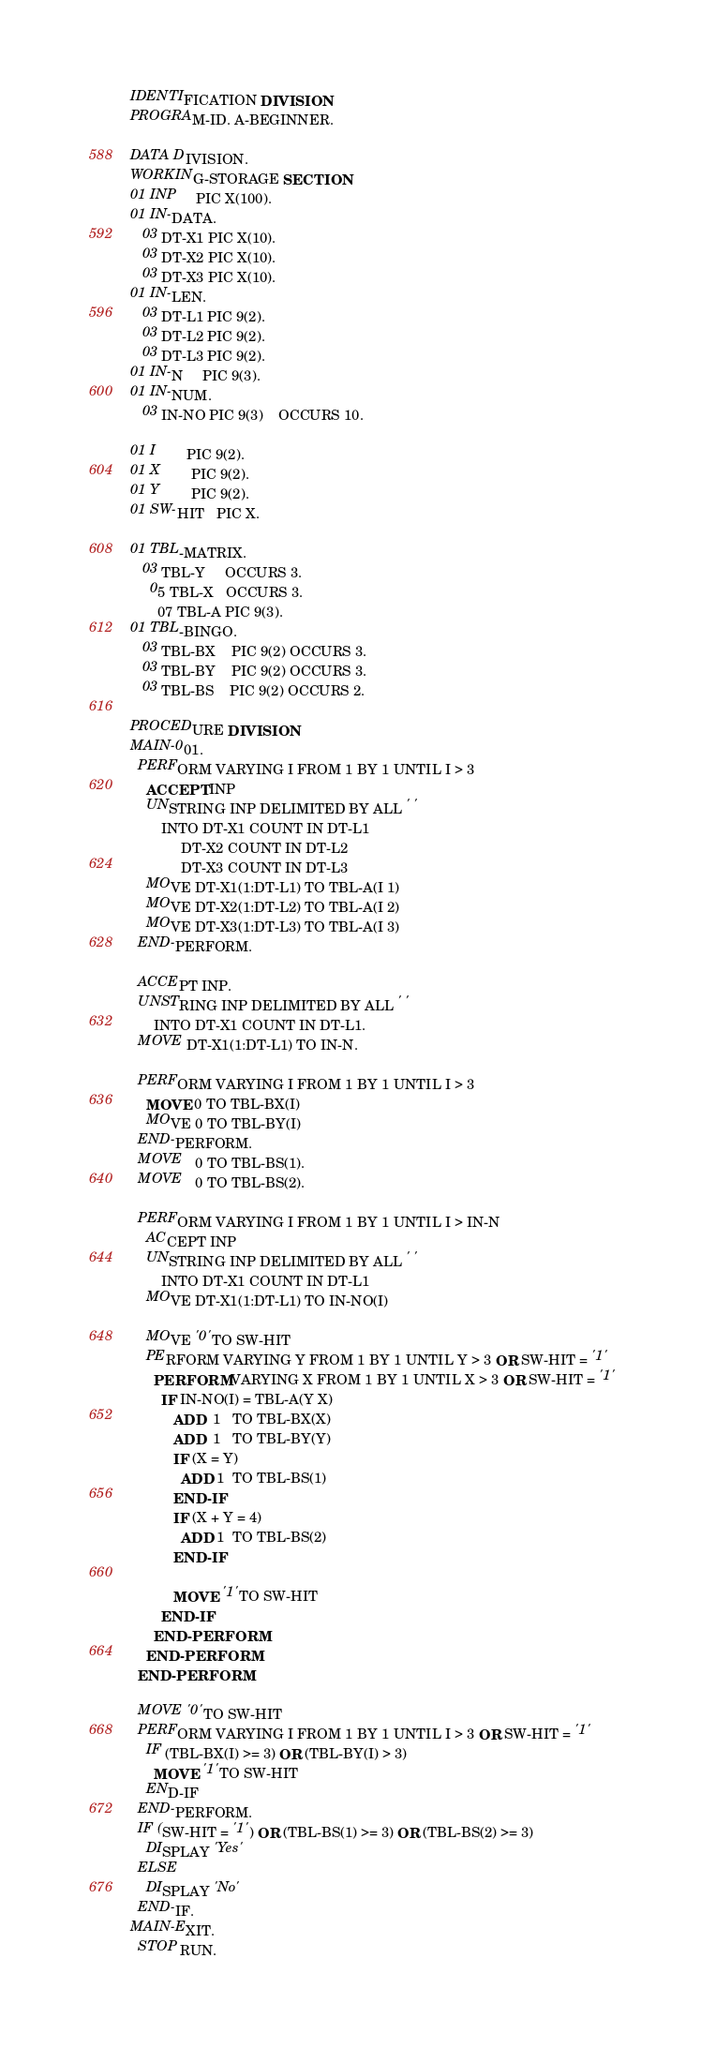Convert code to text. <code><loc_0><loc_0><loc_500><loc_500><_COBOL_>IDENTIFICATION DIVISION.
PROGRAM-ID. A-BEGINNER.
 
DATA DIVISION.
WORKING-STORAGE SECTION.
01 INP     PIC X(100).
01 IN-DATA.
   03 DT-X1 PIC X(10).
   03 DT-X2 PIC X(10).
   03 DT-X3 PIC X(10).
01 IN-LEN.
   03 DT-L1 PIC 9(2).
   03 DT-L2 PIC 9(2).
   03 DT-L3 PIC 9(2).
01 IN-N     PIC 9(3).
01 IN-NUM.
   03 IN-NO PIC 9(3)    OCCURS 10.

01 I        PIC 9(2).
01 X        PIC 9(2). 
01 Y        PIC 9(2). 
01 SW-HIT   PIC X.

01 TBL-MATRIX.
   03 TBL-Y     OCCURS 3.
     05 TBL-X   OCCURS 3.
       07 TBL-A PIC 9(3).
01 TBL-BINGO.
   03 TBL-BX    PIC 9(2) OCCURS 3.
   03 TBL-BY    PIC 9(2) OCCURS 3.
   03 TBL-BS    PIC 9(2) OCCURS 2.

PROCEDURE DIVISION.
MAIN-001.
  PERFORM VARYING I FROM 1 BY 1 UNTIL I > 3
    ACCEPT INP
    UNSTRING INP DELIMITED BY ALL ' '
        INTO DT-X1 COUNT IN DT-L1
             DT-X2 COUNT IN DT-L2
             DT-X3 COUNT IN DT-L3
    MOVE DT-X1(1:DT-L1) TO TBL-A(I 1)
    MOVE DT-X2(1:DT-L2) TO TBL-A(I 2)
    MOVE DT-X3(1:DT-L3) TO TBL-A(I 3)
  END-PERFORM. 

  ACCEPT INP.
  UNSTRING INP DELIMITED BY ALL ' '
      INTO DT-X1 COUNT IN DT-L1.
  MOVE DT-X1(1:DT-L1) TO IN-N.

  PERFORM VARYING I FROM 1 BY 1 UNTIL I > 3
    MOVE 0 TO TBL-BX(I)
    MOVE 0 TO TBL-BY(I)
  END-PERFORM.
  MOVE   0 TO TBL-BS(1).
  MOVE   0 TO TBL-BS(2).  

  PERFORM VARYING I FROM 1 BY 1 UNTIL I > IN-N
    ACCEPT INP
    UNSTRING INP DELIMITED BY ALL ' '
        INTO DT-X1 COUNT IN DT-L1
    MOVE DT-X1(1:DT-L1) TO IN-NO(I)

    MOVE '0' TO SW-HIT
    PERFORM VARYING Y FROM 1 BY 1 UNTIL Y > 3 OR SW-HIT = '1'
      PERFORM VARYING X FROM 1 BY 1 UNTIL X > 3 OR SW-HIT = '1'
        IF IN-NO(I) = TBL-A(Y X)
           ADD  1   TO TBL-BX(X)
           ADD  1   TO TBL-BY(Y)
           IF (X = Y)
             ADD 1  TO TBL-BS(1)
           END-IF
           IF (X + Y = 4)
             ADD 1  TO TBL-BS(2)
           END-IF
 
           MOVE '1' TO SW-HIT
        END-IF
      END-PERFORM 
    END-PERFORM
  END-PERFORM.
  
  MOVE '0' TO SW-HIT
  PERFORM VARYING I FROM 1 BY 1 UNTIL I > 3 OR SW-HIT = '1'
    IF (TBL-BX(I) >= 3) OR (TBL-BY(I) > 3)
      MOVE '1' TO SW-HIT
    END-IF 
  END-PERFORM.
  IF (SW-HIT = '1' ) OR (TBL-BS(1) >= 3) OR (TBL-BS(2) >= 3)
    DISPLAY 'Yes'
  ELSE
    DISPLAY 'No' 
  END-IF.
MAIN-EXIT.
  STOP RUN.</code> 